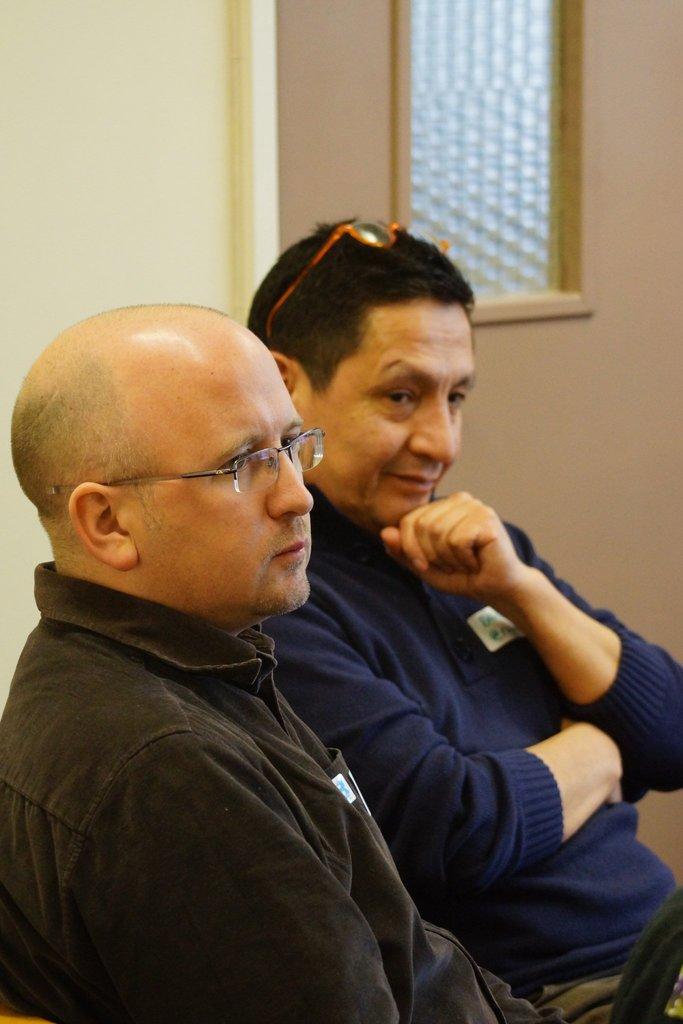Could you give a brief overview of what you see in this image? In this picture we can able to two persons sitting, one person wearing a black shirt, and the other person is wearing a blue color t-shirt, and we can able to see a window, we can see a wall here. 